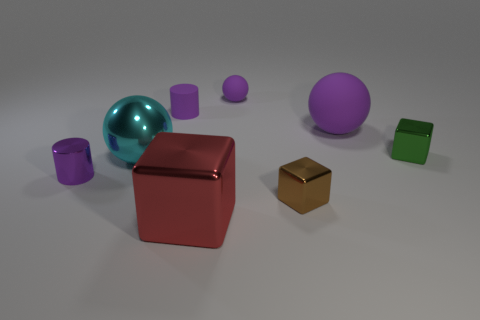Can you tell me what the objects are made of? Although I cannot determine the exact material composition from an image alone, the objects in the image appear to be computer-generated and designed to mimic materials like metal for the small golden cube and rubber or plastic for the colored spheres and cubes.  Are there any reflective surfaces visible? Yes, several objects in the image have reflective surfaces. Specifically, the teal and purple spheres, as well as the smaller green cube, exhibit reflective qualities that suggest a glossy, potentially polished finish. 